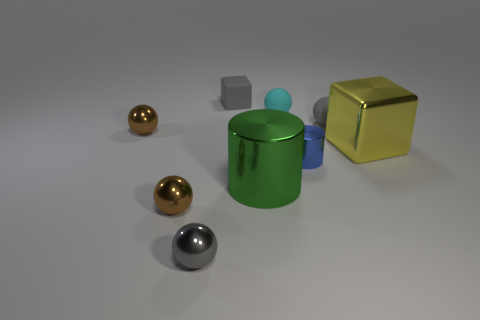There is a block on the right side of the gray matte cube; what is its color?
Keep it short and to the point. Yellow. There is a cyan thing that is the same size as the blue thing; what material is it?
Offer a terse response. Rubber. How many other objects are the same material as the big cylinder?
Give a very brief answer. 5. There is a sphere that is both right of the small gray rubber block and on the left side of the small gray rubber ball; what color is it?
Your answer should be very brief. Cyan. How many things are either tiny spheres right of the cyan ball or big green shiny objects?
Keep it short and to the point. 2. What number of other objects are there of the same color as the small cylinder?
Provide a succinct answer. 0. Is the number of small blue objects left of the green metallic cylinder the same as the number of matte spheres?
Offer a very short reply. No. There is a small gray ball that is on the left side of the tiny metallic thing that is to the right of the small matte block; how many tiny rubber blocks are to the left of it?
Your answer should be very brief. 0. Is there anything else that is the same size as the gray rubber ball?
Provide a short and direct response. Yes. Does the blue metallic object have the same size as the gray matte object that is to the left of the big green object?
Provide a short and direct response. Yes. 